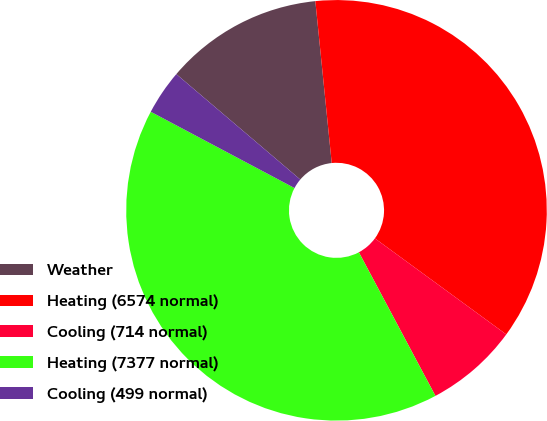Convert chart. <chart><loc_0><loc_0><loc_500><loc_500><pie_chart><fcel>Weather<fcel>Heating (6574 normal)<fcel>Cooling (714 normal)<fcel>Heating (7377 normal)<fcel>Cooling (499 normal)<nl><fcel>12.18%<fcel>36.65%<fcel>7.16%<fcel>40.56%<fcel>3.45%<nl></chart> 